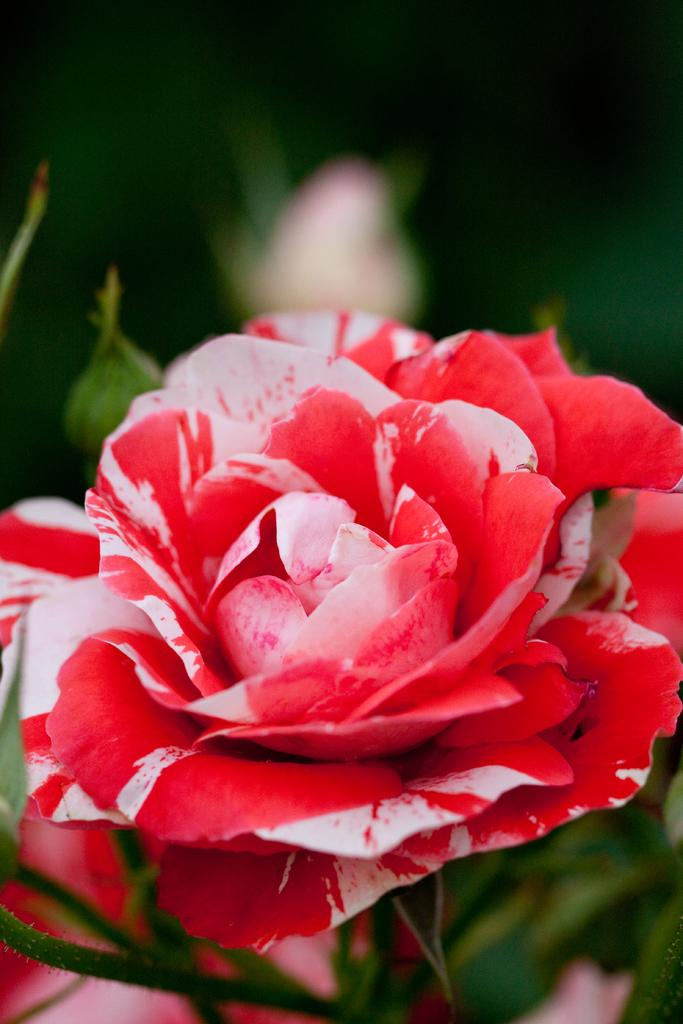What is the main subject of the image? There is a flower in the image. What can be seen in the background of the image? There are leaves and flowers in the background of the image. How many cherries are hanging from the flower in the image? There are no cherries present in the image. What type of toy can be seen interacting with the flower in the image? There are no toys present in the image. Where is the calculator located in the image? There is no calculator present in the image. 